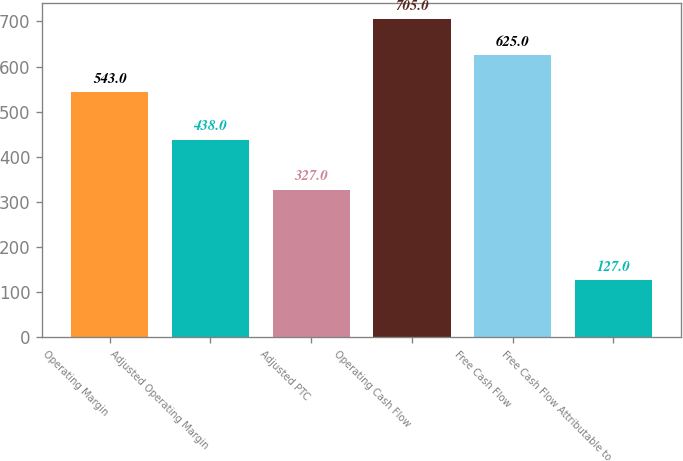Convert chart. <chart><loc_0><loc_0><loc_500><loc_500><bar_chart><fcel>Operating Margin<fcel>Adjusted Operating Margin<fcel>Adjusted PTC<fcel>Operating Cash Flow<fcel>Free Cash Flow<fcel>Free Cash Flow Attributable to<nl><fcel>543<fcel>438<fcel>327<fcel>705<fcel>625<fcel>127<nl></chart> 